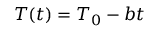<formula> <loc_0><loc_0><loc_500><loc_500>T ( t ) = T _ { 0 } - b t</formula> 